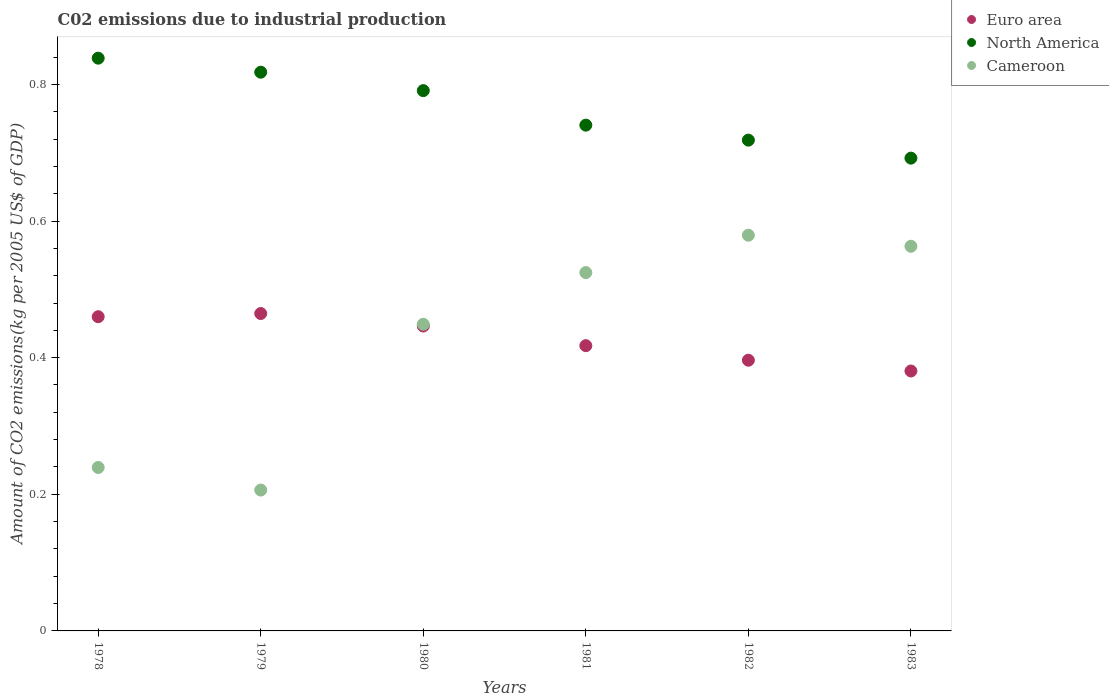How many different coloured dotlines are there?
Keep it short and to the point. 3. What is the amount of CO2 emitted due to industrial production in Euro area in 1979?
Offer a very short reply. 0.46. Across all years, what is the maximum amount of CO2 emitted due to industrial production in Cameroon?
Keep it short and to the point. 0.58. Across all years, what is the minimum amount of CO2 emitted due to industrial production in Cameroon?
Ensure brevity in your answer.  0.21. In which year was the amount of CO2 emitted due to industrial production in North America maximum?
Provide a succinct answer. 1978. In which year was the amount of CO2 emitted due to industrial production in Cameroon minimum?
Provide a succinct answer. 1979. What is the total amount of CO2 emitted due to industrial production in North America in the graph?
Make the answer very short. 4.6. What is the difference between the amount of CO2 emitted due to industrial production in North America in 1979 and that in 1983?
Offer a terse response. 0.13. What is the difference between the amount of CO2 emitted due to industrial production in Cameroon in 1979 and the amount of CO2 emitted due to industrial production in Euro area in 1982?
Offer a very short reply. -0.19. What is the average amount of CO2 emitted due to industrial production in Euro area per year?
Your answer should be very brief. 0.43. In the year 1981, what is the difference between the amount of CO2 emitted due to industrial production in Euro area and amount of CO2 emitted due to industrial production in North America?
Give a very brief answer. -0.32. What is the ratio of the amount of CO2 emitted due to industrial production in Cameroon in 1979 to that in 1981?
Give a very brief answer. 0.39. Is the amount of CO2 emitted due to industrial production in Euro area in 1981 less than that in 1983?
Your answer should be compact. No. What is the difference between the highest and the second highest amount of CO2 emitted due to industrial production in Cameroon?
Ensure brevity in your answer.  0.02. What is the difference between the highest and the lowest amount of CO2 emitted due to industrial production in North America?
Keep it short and to the point. 0.15. Is the sum of the amount of CO2 emitted due to industrial production in Euro area in 1980 and 1982 greater than the maximum amount of CO2 emitted due to industrial production in Cameroon across all years?
Offer a terse response. Yes. Is it the case that in every year, the sum of the amount of CO2 emitted due to industrial production in Cameroon and amount of CO2 emitted due to industrial production in North America  is greater than the amount of CO2 emitted due to industrial production in Euro area?
Make the answer very short. Yes. Is the amount of CO2 emitted due to industrial production in North America strictly greater than the amount of CO2 emitted due to industrial production in Euro area over the years?
Keep it short and to the point. Yes. What is the difference between two consecutive major ticks on the Y-axis?
Offer a very short reply. 0.2. Does the graph contain any zero values?
Ensure brevity in your answer.  No. Does the graph contain grids?
Give a very brief answer. No. How many legend labels are there?
Offer a very short reply. 3. What is the title of the graph?
Give a very brief answer. C02 emissions due to industrial production. Does "New Zealand" appear as one of the legend labels in the graph?
Provide a short and direct response. No. What is the label or title of the X-axis?
Your response must be concise. Years. What is the label or title of the Y-axis?
Your response must be concise. Amount of CO2 emissions(kg per 2005 US$ of GDP). What is the Amount of CO2 emissions(kg per 2005 US$ of GDP) of Euro area in 1978?
Provide a short and direct response. 0.46. What is the Amount of CO2 emissions(kg per 2005 US$ of GDP) of North America in 1978?
Make the answer very short. 0.84. What is the Amount of CO2 emissions(kg per 2005 US$ of GDP) of Cameroon in 1978?
Provide a succinct answer. 0.24. What is the Amount of CO2 emissions(kg per 2005 US$ of GDP) in Euro area in 1979?
Give a very brief answer. 0.46. What is the Amount of CO2 emissions(kg per 2005 US$ of GDP) in North America in 1979?
Your response must be concise. 0.82. What is the Amount of CO2 emissions(kg per 2005 US$ of GDP) in Cameroon in 1979?
Ensure brevity in your answer.  0.21. What is the Amount of CO2 emissions(kg per 2005 US$ of GDP) in Euro area in 1980?
Ensure brevity in your answer.  0.45. What is the Amount of CO2 emissions(kg per 2005 US$ of GDP) of North America in 1980?
Give a very brief answer. 0.79. What is the Amount of CO2 emissions(kg per 2005 US$ of GDP) of Cameroon in 1980?
Your answer should be compact. 0.45. What is the Amount of CO2 emissions(kg per 2005 US$ of GDP) in Euro area in 1981?
Keep it short and to the point. 0.42. What is the Amount of CO2 emissions(kg per 2005 US$ of GDP) in North America in 1981?
Make the answer very short. 0.74. What is the Amount of CO2 emissions(kg per 2005 US$ of GDP) in Cameroon in 1981?
Give a very brief answer. 0.52. What is the Amount of CO2 emissions(kg per 2005 US$ of GDP) of Euro area in 1982?
Provide a succinct answer. 0.4. What is the Amount of CO2 emissions(kg per 2005 US$ of GDP) in North America in 1982?
Give a very brief answer. 0.72. What is the Amount of CO2 emissions(kg per 2005 US$ of GDP) of Cameroon in 1982?
Your answer should be compact. 0.58. What is the Amount of CO2 emissions(kg per 2005 US$ of GDP) in Euro area in 1983?
Offer a terse response. 0.38. What is the Amount of CO2 emissions(kg per 2005 US$ of GDP) of North America in 1983?
Ensure brevity in your answer.  0.69. What is the Amount of CO2 emissions(kg per 2005 US$ of GDP) in Cameroon in 1983?
Ensure brevity in your answer.  0.56. Across all years, what is the maximum Amount of CO2 emissions(kg per 2005 US$ of GDP) in Euro area?
Give a very brief answer. 0.46. Across all years, what is the maximum Amount of CO2 emissions(kg per 2005 US$ of GDP) in North America?
Keep it short and to the point. 0.84. Across all years, what is the maximum Amount of CO2 emissions(kg per 2005 US$ of GDP) in Cameroon?
Keep it short and to the point. 0.58. Across all years, what is the minimum Amount of CO2 emissions(kg per 2005 US$ of GDP) in Euro area?
Your answer should be compact. 0.38. Across all years, what is the minimum Amount of CO2 emissions(kg per 2005 US$ of GDP) in North America?
Give a very brief answer. 0.69. Across all years, what is the minimum Amount of CO2 emissions(kg per 2005 US$ of GDP) in Cameroon?
Offer a terse response. 0.21. What is the total Amount of CO2 emissions(kg per 2005 US$ of GDP) of Euro area in the graph?
Your answer should be very brief. 2.57. What is the total Amount of CO2 emissions(kg per 2005 US$ of GDP) in North America in the graph?
Provide a succinct answer. 4.6. What is the total Amount of CO2 emissions(kg per 2005 US$ of GDP) in Cameroon in the graph?
Offer a very short reply. 2.56. What is the difference between the Amount of CO2 emissions(kg per 2005 US$ of GDP) in Euro area in 1978 and that in 1979?
Provide a short and direct response. -0. What is the difference between the Amount of CO2 emissions(kg per 2005 US$ of GDP) of North America in 1978 and that in 1979?
Ensure brevity in your answer.  0.02. What is the difference between the Amount of CO2 emissions(kg per 2005 US$ of GDP) in Cameroon in 1978 and that in 1979?
Your answer should be compact. 0.03. What is the difference between the Amount of CO2 emissions(kg per 2005 US$ of GDP) of Euro area in 1978 and that in 1980?
Offer a terse response. 0.01. What is the difference between the Amount of CO2 emissions(kg per 2005 US$ of GDP) of North America in 1978 and that in 1980?
Your answer should be very brief. 0.05. What is the difference between the Amount of CO2 emissions(kg per 2005 US$ of GDP) of Cameroon in 1978 and that in 1980?
Your answer should be very brief. -0.21. What is the difference between the Amount of CO2 emissions(kg per 2005 US$ of GDP) in Euro area in 1978 and that in 1981?
Offer a very short reply. 0.04. What is the difference between the Amount of CO2 emissions(kg per 2005 US$ of GDP) in North America in 1978 and that in 1981?
Give a very brief answer. 0.1. What is the difference between the Amount of CO2 emissions(kg per 2005 US$ of GDP) in Cameroon in 1978 and that in 1981?
Your response must be concise. -0.29. What is the difference between the Amount of CO2 emissions(kg per 2005 US$ of GDP) of Euro area in 1978 and that in 1982?
Offer a terse response. 0.06. What is the difference between the Amount of CO2 emissions(kg per 2005 US$ of GDP) of North America in 1978 and that in 1982?
Your answer should be compact. 0.12. What is the difference between the Amount of CO2 emissions(kg per 2005 US$ of GDP) of Cameroon in 1978 and that in 1982?
Your answer should be very brief. -0.34. What is the difference between the Amount of CO2 emissions(kg per 2005 US$ of GDP) of Euro area in 1978 and that in 1983?
Keep it short and to the point. 0.08. What is the difference between the Amount of CO2 emissions(kg per 2005 US$ of GDP) of North America in 1978 and that in 1983?
Ensure brevity in your answer.  0.15. What is the difference between the Amount of CO2 emissions(kg per 2005 US$ of GDP) in Cameroon in 1978 and that in 1983?
Provide a succinct answer. -0.32. What is the difference between the Amount of CO2 emissions(kg per 2005 US$ of GDP) in Euro area in 1979 and that in 1980?
Your answer should be very brief. 0.02. What is the difference between the Amount of CO2 emissions(kg per 2005 US$ of GDP) of North America in 1979 and that in 1980?
Your answer should be compact. 0.03. What is the difference between the Amount of CO2 emissions(kg per 2005 US$ of GDP) of Cameroon in 1979 and that in 1980?
Ensure brevity in your answer.  -0.24. What is the difference between the Amount of CO2 emissions(kg per 2005 US$ of GDP) in Euro area in 1979 and that in 1981?
Provide a succinct answer. 0.05. What is the difference between the Amount of CO2 emissions(kg per 2005 US$ of GDP) in North America in 1979 and that in 1981?
Make the answer very short. 0.08. What is the difference between the Amount of CO2 emissions(kg per 2005 US$ of GDP) of Cameroon in 1979 and that in 1981?
Provide a short and direct response. -0.32. What is the difference between the Amount of CO2 emissions(kg per 2005 US$ of GDP) in Euro area in 1979 and that in 1982?
Make the answer very short. 0.07. What is the difference between the Amount of CO2 emissions(kg per 2005 US$ of GDP) of North America in 1979 and that in 1982?
Your answer should be compact. 0.1. What is the difference between the Amount of CO2 emissions(kg per 2005 US$ of GDP) in Cameroon in 1979 and that in 1982?
Your answer should be very brief. -0.37. What is the difference between the Amount of CO2 emissions(kg per 2005 US$ of GDP) in Euro area in 1979 and that in 1983?
Keep it short and to the point. 0.08. What is the difference between the Amount of CO2 emissions(kg per 2005 US$ of GDP) in North America in 1979 and that in 1983?
Provide a short and direct response. 0.13. What is the difference between the Amount of CO2 emissions(kg per 2005 US$ of GDP) in Cameroon in 1979 and that in 1983?
Offer a very short reply. -0.36. What is the difference between the Amount of CO2 emissions(kg per 2005 US$ of GDP) of Euro area in 1980 and that in 1981?
Your response must be concise. 0.03. What is the difference between the Amount of CO2 emissions(kg per 2005 US$ of GDP) of North America in 1980 and that in 1981?
Give a very brief answer. 0.05. What is the difference between the Amount of CO2 emissions(kg per 2005 US$ of GDP) in Cameroon in 1980 and that in 1981?
Provide a succinct answer. -0.08. What is the difference between the Amount of CO2 emissions(kg per 2005 US$ of GDP) of Euro area in 1980 and that in 1982?
Give a very brief answer. 0.05. What is the difference between the Amount of CO2 emissions(kg per 2005 US$ of GDP) of North America in 1980 and that in 1982?
Ensure brevity in your answer.  0.07. What is the difference between the Amount of CO2 emissions(kg per 2005 US$ of GDP) of Cameroon in 1980 and that in 1982?
Make the answer very short. -0.13. What is the difference between the Amount of CO2 emissions(kg per 2005 US$ of GDP) of Euro area in 1980 and that in 1983?
Make the answer very short. 0.07. What is the difference between the Amount of CO2 emissions(kg per 2005 US$ of GDP) in North America in 1980 and that in 1983?
Offer a terse response. 0.1. What is the difference between the Amount of CO2 emissions(kg per 2005 US$ of GDP) in Cameroon in 1980 and that in 1983?
Offer a terse response. -0.11. What is the difference between the Amount of CO2 emissions(kg per 2005 US$ of GDP) in Euro area in 1981 and that in 1982?
Provide a succinct answer. 0.02. What is the difference between the Amount of CO2 emissions(kg per 2005 US$ of GDP) of North America in 1981 and that in 1982?
Ensure brevity in your answer.  0.02. What is the difference between the Amount of CO2 emissions(kg per 2005 US$ of GDP) in Cameroon in 1981 and that in 1982?
Keep it short and to the point. -0.05. What is the difference between the Amount of CO2 emissions(kg per 2005 US$ of GDP) in Euro area in 1981 and that in 1983?
Your response must be concise. 0.04. What is the difference between the Amount of CO2 emissions(kg per 2005 US$ of GDP) of North America in 1981 and that in 1983?
Provide a short and direct response. 0.05. What is the difference between the Amount of CO2 emissions(kg per 2005 US$ of GDP) in Cameroon in 1981 and that in 1983?
Provide a succinct answer. -0.04. What is the difference between the Amount of CO2 emissions(kg per 2005 US$ of GDP) of Euro area in 1982 and that in 1983?
Your answer should be very brief. 0.02. What is the difference between the Amount of CO2 emissions(kg per 2005 US$ of GDP) of North America in 1982 and that in 1983?
Your answer should be compact. 0.03. What is the difference between the Amount of CO2 emissions(kg per 2005 US$ of GDP) of Cameroon in 1982 and that in 1983?
Ensure brevity in your answer.  0.02. What is the difference between the Amount of CO2 emissions(kg per 2005 US$ of GDP) of Euro area in 1978 and the Amount of CO2 emissions(kg per 2005 US$ of GDP) of North America in 1979?
Offer a very short reply. -0.36. What is the difference between the Amount of CO2 emissions(kg per 2005 US$ of GDP) in Euro area in 1978 and the Amount of CO2 emissions(kg per 2005 US$ of GDP) in Cameroon in 1979?
Your response must be concise. 0.25. What is the difference between the Amount of CO2 emissions(kg per 2005 US$ of GDP) of North America in 1978 and the Amount of CO2 emissions(kg per 2005 US$ of GDP) of Cameroon in 1979?
Provide a succinct answer. 0.63. What is the difference between the Amount of CO2 emissions(kg per 2005 US$ of GDP) of Euro area in 1978 and the Amount of CO2 emissions(kg per 2005 US$ of GDP) of North America in 1980?
Your answer should be very brief. -0.33. What is the difference between the Amount of CO2 emissions(kg per 2005 US$ of GDP) in Euro area in 1978 and the Amount of CO2 emissions(kg per 2005 US$ of GDP) in Cameroon in 1980?
Your answer should be very brief. 0.01. What is the difference between the Amount of CO2 emissions(kg per 2005 US$ of GDP) in North America in 1978 and the Amount of CO2 emissions(kg per 2005 US$ of GDP) in Cameroon in 1980?
Your response must be concise. 0.39. What is the difference between the Amount of CO2 emissions(kg per 2005 US$ of GDP) in Euro area in 1978 and the Amount of CO2 emissions(kg per 2005 US$ of GDP) in North America in 1981?
Make the answer very short. -0.28. What is the difference between the Amount of CO2 emissions(kg per 2005 US$ of GDP) of Euro area in 1978 and the Amount of CO2 emissions(kg per 2005 US$ of GDP) of Cameroon in 1981?
Provide a short and direct response. -0.06. What is the difference between the Amount of CO2 emissions(kg per 2005 US$ of GDP) of North America in 1978 and the Amount of CO2 emissions(kg per 2005 US$ of GDP) of Cameroon in 1981?
Provide a succinct answer. 0.31. What is the difference between the Amount of CO2 emissions(kg per 2005 US$ of GDP) in Euro area in 1978 and the Amount of CO2 emissions(kg per 2005 US$ of GDP) in North America in 1982?
Provide a succinct answer. -0.26. What is the difference between the Amount of CO2 emissions(kg per 2005 US$ of GDP) of Euro area in 1978 and the Amount of CO2 emissions(kg per 2005 US$ of GDP) of Cameroon in 1982?
Offer a very short reply. -0.12. What is the difference between the Amount of CO2 emissions(kg per 2005 US$ of GDP) of North America in 1978 and the Amount of CO2 emissions(kg per 2005 US$ of GDP) of Cameroon in 1982?
Ensure brevity in your answer.  0.26. What is the difference between the Amount of CO2 emissions(kg per 2005 US$ of GDP) of Euro area in 1978 and the Amount of CO2 emissions(kg per 2005 US$ of GDP) of North America in 1983?
Give a very brief answer. -0.23. What is the difference between the Amount of CO2 emissions(kg per 2005 US$ of GDP) in Euro area in 1978 and the Amount of CO2 emissions(kg per 2005 US$ of GDP) in Cameroon in 1983?
Keep it short and to the point. -0.1. What is the difference between the Amount of CO2 emissions(kg per 2005 US$ of GDP) of North America in 1978 and the Amount of CO2 emissions(kg per 2005 US$ of GDP) of Cameroon in 1983?
Your answer should be compact. 0.28. What is the difference between the Amount of CO2 emissions(kg per 2005 US$ of GDP) of Euro area in 1979 and the Amount of CO2 emissions(kg per 2005 US$ of GDP) of North America in 1980?
Provide a short and direct response. -0.33. What is the difference between the Amount of CO2 emissions(kg per 2005 US$ of GDP) in Euro area in 1979 and the Amount of CO2 emissions(kg per 2005 US$ of GDP) in Cameroon in 1980?
Your answer should be compact. 0.02. What is the difference between the Amount of CO2 emissions(kg per 2005 US$ of GDP) of North America in 1979 and the Amount of CO2 emissions(kg per 2005 US$ of GDP) of Cameroon in 1980?
Your answer should be very brief. 0.37. What is the difference between the Amount of CO2 emissions(kg per 2005 US$ of GDP) of Euro area in 1979 and the Amount of CO2 emissions(kg per 2005 US$ of GDP) of North America in 1981?
Provide a succinct answer. -0.28. What is the difference between the Amount of CO2 emissions(kg per 2005 US$ of GDP) of Euro area in 1979 and the Amount of CO2 emissions(kg per 2005 US$ of GDP) of Cameroon in 1981?
Ensure brevity in your answer.  -0.06. What is the difference between the Amount of CO2 emissions(kg per 2005 US$ of GDP) in North America in 1979 and the Amount of CO2 emissions(kg per 2005 US$ of GDP) in Cameroon in 1981?
Make the answer very short. 0.29. What is the difference between the Amount of CO2 emissions(kg per 2005 US$ of GDP) of Euro area in 1979 and the Amount of CO2 emissions(kg per 2005 US$ of GDP) of North America in 1982?
Keep it short and to the point. -0.25. What is the difference between the Amount of CO2 emissions(kg per 2005 US$ of GDP) of Euro area in 1979 and the Amount of CO2 emissions(kg per 2005 US$ of GDP) of Cameroon in 1982?
Provide a succinct answer. -0.11. What is the difference between the Amount of CO2 emissions(kg per 2005 US$ of GDP) of North America in 1979 and the Amount of CO2 emissions(kg per 2005 US$ of GDP) of Cameroon in 1982?
Offer a terse response. 0.24. What is the difference between the Amount of CO2 emissions(kg per 2005 US$ of GDP) of Euro area in 1979 and the Amount of CO2 emissions(kg per 2005 US$ of GDP) of North America in 1983?
Provide a short and direct response. -0.23. What is the difference between the Amount of CO2 emissions(kg per 2005 US$ of GDP) of Euro area in 1979 and the Amount of CO2 emissions(kg per 2005 US$ of GDP) of Cameroon in 1983?
Give a very brief answer. -0.1. What is the difference between the Amount of CO2 emissions(kg per 2005 US$ of GDP) of North America in 1979 and the Amount of CO2 emissions(kg per 2005 US$ of GDP) of Cameroon in 1983?
Your response must be concise. 0.25. What is the difference between the Amount of CO2 emissions(kg per 2005 US$ of GDP) of Euro area in 1980 and the Amount of CO2 emissions(kg per 2005 US$ of GDP) of North America in 1981?
Offer a terse response. -0.29. What is the difference between the Amount of CO2 emissions(kg per 2005 US$ of GDP) in Euro area in 1980 and the Amount of CO2 emissions(kg per 2005 US$ of GDP) in Cameroon in 1981?
Your answer should be compact. -0.08. What is the difference between the Amount of CO2 emissions(kg per 2005 US$ of GDP) of North America in 1980 and the Amount of CO2 emissions(kg per 2005 US$ of GDP) of Cameroon in 1981?
Your answer should be compact. 0.27. What is the difference between the Amount of CO2 emissions(kg per 2005 US$ of GDP) in Euro area in 1980 and the Amount of CO2 emissions(kg per 2005 US$ of GDP) in North America in 1982?
Offer a very short reply. -0.27. What is the difference between the Amount of CO2 emissions(kg per 2005 US$ of GDP) in Euro area in 1980 and the Amount of CO2 emissions(kg per 2005 US$ of GDP) in Cameroon in 1982?
Give a very brief answer. -0.13. What is the difference between the Amount of CO2 emissions(kg per 2005 US$ of GDP) in North America in 1980 and the Amount of CO2 emissions(kg per 2005 US$ of GDP) in Cameroon in 1982?
Offer a terse response. 0.21. What is the difference between the Amount of CO2 emissions(kg per 2005 US$ of GDP) of Euro area in 1980 and the Amount of CO2 emissions(kg per 2005 US$ of GDP) of North America in 1983?
Keep it short and to the point. -0.25. What is the difference between the Amount of CO2 emissions(kg per 2005 US$ of GDP) of Euro area in 1980 and the Amount of CO2 emissions(kg per 2005 US$ of GDP) of Cameroon in 1983?
Provide a short and direct response. -0.12. What is the difference between the Amount of CO2 emissions(kg per 2005 US$ of GDP) of North America in 1980 and the Amount of CO2 emissions(kg per 2005 US$ of GDP) of Cameroon in 1983?
Offer a terse response. 0.23. What is the difference between the Amount of CO2 emissions(kg per 2005 US$ of GDP) of Euro area in 1981 and the Amount of CO2 emissions(kg per 2005 US$ of GDP) of North America in 1982?
Provide a succinct answer. -0.3. What is the difference between the Amount of CO2 emissions(kg per 2005 US$ of GDP) in Euro area in 1981 and the Amount of CO2 emissions(kg per 2005 US$ of GDP) in Cameroon in 1982?
Your answer should be compact. -0.16. What is the difference between the Amount of CO2 emissions(kg per 2005 US$ of GDP) in North America in 1981 and the Amount of CO2 emissions(kg per 2005 US$ of GDP) in Cameroon in 1982?
Keep it short and to the point. 0.16. What is the difference between the Amount of CO2 emissions(kg per 2005 US$ of GDP) of Euro area in 1981 and the Amount of CO2 emissions(kg per 2005 US$ of GDP) of North America in 1983?
Offer a terse response. -0.27. What is the difference between the Amount of CO2 emissions(kg per 2005 US$ of GDP) in Euro area in 1981 and the Amount of CO2 emissions(kg per 2005 US$ of GDP) in Cameroon in 1983?
Keep it short and to the point. -0.15. What is the difference between the Amount of CO2 emissions(kg per 2005 US$ of GDP) in North America in 1981 and the Amount of CO2 emissions(kg per 2005 US$ of GDP) in Cameroon in 1983?
Provide a short and direct response. 0.18. What is the difference between the Amount of CO2 emissions(kg per 2005 US$ of GDP) in Euro area in 1982 and the Amount of CO2 emissions(kg per 2005 US$ of GDP) in North America in 1983?
Provide a short and direct response. -0.3. What is the difference between the Amount of CO2 emissions(kg per 2005 US$ of GDP) in Euro area in 1982 and the Amount of CO2 emissions(kg per 2005 US$ of GDP) in Cameroon in 1983?
Your response must be concise. -0.17. What is the difference between the Amount of CO2 emissions(kg per 2005 US$ of GDP) in North America in 1982 and the Amount of CO2 emissions(kg per 2005 US$ of GDP) in Cameroon in 1983?
Your response must be concise. 0.16. What is the average Amount of CO2 emissions(kg per 2005 US$ of GDP) of Euro area per year?
Provide a short and direct response. 0.43. What is the average Amount of CO2 emissions(kg per 2005 US$ of GDP) of North America per year?
Ensure brevity in your answer.  0.77. What is the average Amount of CO2 emissions(kg per 2005 US$ of GDP) in Cameroon per year?
Offer a very short reply. 0.43. In the year 1978, what is the difference between the Amount of CO2 emissions(kg per 2005 US$ of GDP) in Euro area and Amount of CO2 emissions(kg per 2005 US$ of GDP) in North America?
Ensure brevity in your answer.  -0.38. In the year 1978, what is the difference between the Amount of CO2 emissions(kg per 2005 US$ of GDP) in Euro area and Amount of CO2 emissions(kg per 2005 US$ of GDP) in Cameroon?
Offer a very short reply. 0.22. In the year 1978, what is the difference between the Amount of CO2 emissions(kg per 2005 US$ of GDP) in North America and Amount of CO2 emissions(kg per 2005 US$ of GDP) in Cameroon?
Provide a succinct answer. 0.6. In the year 1979, what is the difference between the Amount of CO2 emissions(kg per 2005 US$ of GDP) in Euro area and Amount of CO2 emissions(kg per 2005 US$ of GDP) in North America?
Provide a short and direct response. -0.35. In the year 1979, what is the difference between the Amount of CO2 emissions(kg per 2005 US$ of GDP) of Euro area and Amount of CO2 emissions(kg per 2005 US$ of GDP) of Cameroon?
Your response must be concise. 0.26. In the year 1979, what is the difference between the Amount of CO2 emissions(kg per 2005 US$ of GDP) of North America and Amount of CO2 emissions(kg per 2005 US$ of GDP) of Cameroon?
Your answer should be very brief. 0.61. In the year 1980, what is the difference between the Amount of CO2 emissions(kg per 2005 US$ of GDP) in Euro area and Amount of CO2 emissions(kg per 2005 US$ of GDP) in North America?
Your answer should be compact. -0.34. In the year 1980, what is the difference between the Amount of CO2 emissions(kg per 2005 US$ of GDP) in Euro area and Amount of CO2 emissions(kg per 2005 US$ of GDP) in Cameroon?
Offer a very short reply. -0. In the year 1980, what is the difference between the Amount of CO2 emissions(kg per 2005 US$ of GDP) in North America and Amount of CO2 emissions(kg per 2005 US$ of GDP) in Cameroon?
Provide a short and direct response. 0.34. In the year 1981, what is the difference between the Amount of CO2 emissions(kg per 2005 US$ of GDP) in Euro area and Amount of CO2 emissions(kg per 2005 US$ of GDP) in North America?
Your answer should be very brief. -0.32. In the year 1981, what is the difference between the Amount of CO2 emissions(kg per 2005 US$ of GDP) in Euro area and Amount of CO2 emissions(kg per 2005 US$ of GDP) in Cameroon?
Keep it short and to the point. -0.11. In the year 1981, what is the difference between the Amount of CO2 emissions(kg per 2005 US$ of GDP) in North America and Amount of CO2 emissions(kg per 2005 US$ of GDP) in Cameroon?
Provide a short and direct response. 0.22. In the year 1982, what is the difference between the Amount of CO2 emissions(kg per 2005 US$ of GDP) in Euro area and Amount of CO2 emissions(kg per 2005 US$ of GDP) in North America?
Your answer should be compact. -0.32. In the year 1982, what is the difference between the Amount of CO2 emissions(kg per 2005 US$ of GDP) of Euro area and Amount of CO2 emissions(kg per 2005 US$ of GDP) of Cameroon?
Ensure brevity in your answer.  -0.18. In the year 1982, what is the difference between the Amount of CO2 emissions(kg per 2005 US$ of GDP) in North America and Amount of CO2 emissions(kg per 2005 US$ of GDP) in Cameroon?
Your answer should be compact. 0.14. In the year 1983, what is the difference between the Amount of CO2 emissions(kg per 2005 US$ of GDP) of Euro area and Amount of CO2 emissions(kg per 2005 US$ of GDP) of North America?
Provide a short and direct response. -0.31. In the year 1983, what is the difference between the Amount of CO2 emissions(kg per 2005 US$ of GDP) in Euro area and Amount of CO2 emissions(kg per 2005 US$ of GDP) in Cameroon?
Offer a very short reply. -0.18. In the year 1983, what is the difference between the Amount of CO2 emissions(kg per 2005 US$ of GDP) in North America and Amount of CO2 emissions(kg per 2005 US$ of GDP) in Cameroon?
Your answer should be compact. 0.13. What is the ratio of the Amount of CO2 emissions(kg per 2005 US$ of GDP) of Euro area in 1978 to that in 1979?
Your answer should be very brief. 0.99. What is the ratio of the Amount of CO2 emissions(kg per 2005 US$ of GDP) in North America in 1978 to that in 1979?
Give a very brief answer. 1.03. What is the ratio of the Amount of CO2 emissions(kg per 2005 US$ of GDP) in Cameroon in 1978 to that in 1979?
Ensure brevity in your answer.  1.16. What is the ratio of the Amount of CO2 emissions(kg per 2005 US$ of GDP) of Euro area in 1978 to that in 1980?
Make the answer very short. 1.03. What is the ratio of the Amount of CO2 emissions(kg per 2005 US$ of GDP) in North America in 1978 to that in 1980?
Provide a succinct answer. 1.06. What is the ratio of the Amount of CO2 emissions(kg per 2005 US$ of GDP) of Cameroon in 1978 to that in 1980?
Ensure brevity in your answer.  0.53. What is the ratio of the Amount of CO2 emissions(kg per 2005 US$ of GDP) in Euro area in 1978 to that in 1981?
Provide a succinct answer. 1.1. What is the ratio of the Amount of CO2 emissions(kg per 2005 US$ of GDP) of North America in 1978 to that in 1981?
Give a very brief answer. 1.13. What is the ratio of the Amount of CO2 emissions(kg per 2005 US$ of GDP) of Cameroon in 1978 to that in 1981?
Provide a short and direct response. 0.46. What is the ratio of the Amount of CO2 emissions(kg per 2005 US$ of GDP) in Euro area in 1978 to that in 1982?
Your answer should be compact. 1.16. What is the ratio of the Amount of CO2 emissions(kg per 2005 US$ of GDP) of North America in 1978 to that in 1982?
Keep it short and to the point. 1.17. What is the ratio of the Amount of CO2 emissions(kg per 2005 US$ of GDP) in Cameroon in 1978 to that in 1982?
Your answer should be very brief. 0.41. What is the ratio of the Amount of CO2 emissions(kg per 2005 US$ of GDP) in Euro area in 1978 to that in 1983?
Ensure brevity in your answer.  1.21. What is the ratio of the Amount of CO2 emissions(kg per 2005 US$ of GDP) of North America in 1978 to that in 1983?
Give a very brief answer. 1.21. What is the ratio of the Amount of CO2 emissions(kg per 2005 US$ of GDP) of Cameroon in 1978 to that in 1983?
Provide a short and direct response. 0.42. What is the ratio of the Amount of CO2 emissions(kg per 2005 US$ of GDP) of Euro area in 1979 to that in 1980?
Your answer should be compact. 1.04. What is the ratio of the Amount of CO2 emissions(kg per 2005 US$ of GDP) in North America in 1979 to that in 1980?
Provide a short and direct response. 1.03. What is the ratio of the Amount of CO2 emissions(kg per 2005 US$ of GDP) of Cameroon in 1979 to that in 1980?
Provide a succinct answer. 0.46. What is the ratio of the Amount of CO2 emissions(kg per 2005 US$ of GDP) in Euro area in 1979 to that in 1981?
Offer a terse response. 1.11. What is the ratio of the Amount of CO2 emissions(kg per 2005 US$ of GDP) of North America in 1979 to that in 1981?
Your response must be concise. 1.1. What is the ratio of the Amount of CO2 emissions(kg per 2005 US$ of GDP) of Cameroon in 1979 to that in 1981?
Your answer should be very brief. 0.39. What is the ratio of the Amount of CO2 emissions(kg per 2005 US$ of GDP) of Euro area in 1979 to that in 1982?
Make the answer very short. 1.17. What is the ratio of the Amount of CO2 emissions(kg per 2005 US$ of GDP) of North America in 1979 to that in 1982?
Keep it short and to the point. 1.14. What is the ratio of the Amount of CO2 emissions(kg per 2005 US$ of GDP) of Cameroon in 1979 to that in 1982?
Ensure brevity in your answer.  0.36. What is the ratio of the Amount of CO2 emissions(kg per 2005 US$ of GDP) of Euro area in 1979 to that in 1983?
Make the answer very short. 1.22. What is the ratio of the Amount of CO2 emissions(kg per 2005 US$ of GDP) in North America in 1979 to that in 1983?
Your answer should be compact. 1.18. What is the ratio of the Amount of CO2 emissions(kg per 2005 US$ of GDP) of Cameroon in 1979 to that in 1983?
Ensure brevity in your answer.  0.37. What is the ratio of the Amount of CO2 emissions(kg per 2005 US$ of GDP) of Euro area in 1980 to that in 1981?
Offer a terse response. 1.07. What is the ratio of the Amount of CO2 emissions(kg per 2005 US$ of GDP) of North America in 1980 to that in 1981?
Your response must be concise. 1.07. What is the ratio of the Amount of CO2 emissions(kg per 2005 US$ of GDP) in Cameroon in 1980 to that in 1981?
Your answer should be very brief. 0.86. What is the ratio of the Amount of CO2 emissions(kg per 2005 US$ of GDP) of Euro area in 1980 to that in 1982?
Keep it short and to the point. 1.13. What is the ratio of the Amount of CO2 emissions(kg per 2005 US$ of GDP) of North America in 1980 to that in 1982?
Ensure brevity in your answer.  1.1. What is the ratio of the Amount of CO2 emissions(kg per 2005 US$ of GDP) of Cameroon in 1980 to that in 1982?
Your response must be concise. 0.77. What is the ratio of the Amount of CO2 emissions(kg per 2005 US$ of GDP) in Euro area in 1980 to that in 1983?
Provide a succinct answer. 1.17. What is the ratio of the Amount of CO2 emissions(kg per 2005 US$ of GDP) of North America in 1980 to that in 1983?
Provide a short and direct response. 1.14. What is the ratio of the Amount of CO2 emissions(kg per 2005 US$ of GDP) of Cameroon in 1980 to that in 1983?
Your answer should be very brief. 0.8. What is the ratio of the Amount of CO2 emissions(kg per 2005 US$ of GDP) of Euro area in 1981 to that in 1982?
Your response must be concise. 1.05. What is the ratio of the Amount of CO2 emissions(kg per 2005 US$ of GDP) in North America in 1981 to that in 1982?
Provide a short and direct response. 1.03. What is the ratio of the Amount of CO2 emissions(kg per 2005 US$ of GDP) of Cameroon in 1981 to that in 1982?
Provide a succinct answer. 0.91. What is the ratio of the Amount of CO2 emissions(kg per 2005 US$ of GDP) of Euro area in 1981 to that in 1983?
Your answer should be very brief. 1.1. What is the ratio of the Amount of CO2 emissions(kg per 2005 US$ of GDP) in North America in 1981 to that in 1983?
Ensure brevity in your answer.  1.07. What is the ratio of the Amount of CO2 emissions(kg per 2005 US$ of GDP) in Cameroon in 1981 to that in 1983?
Your answer should be very brief. 0.93. What is the ratio of the Amount of CO2 emissions(kg per 2005 US$ of GDP) of Euro area in 1982 to that in 1983?
Your answer should be very brief. 1.04. What is the ratio of the Amount of CO2 emissions(kg per 2005 US$ of GDP) of North America in 1982 to that in 1983?
Keep it short and to the point. 1.04. What is the ratio of the Amount of CO2 emissions(kg per 2005 US$ of GDP) in Cameroon in 1982 to that in 1983?
Ensure brevity in your answer.  1.03. What is the difference between the highest and the second highest Amount of CO2 emissions(kg per 2005 US$ of GDP) in Euro area?
Keep it short and to the point. 0. What is the difference between the highest and the second highest Amount of CO2 emissions(kg per 2005 US$ of GDP) in North America?
Make the answer very short. 0.02. What is the difference between the highest and the second highest Amount of CO2 emissions(kg per 2005 US$ of GDP) of Cameroon?
Your response must be concise. 0.02. What is the difference between the highest and the lowest Amount of CO2 emissions(kg per 2005 US$ of GDP) of Euro area?
Offer a very short reply. 0.08. What is the difference between the highest and the lowest Amount of CO2 emissions(kg per 2005 US$ of GDP) in North America?
Keep it short and to the point. 0.15. What is the difference between the highest and the lowest Amount of CO2 emissions(kg per 2005 US$ of GDP) in Cameroon?
Provide a succinct answer. 0.37. 